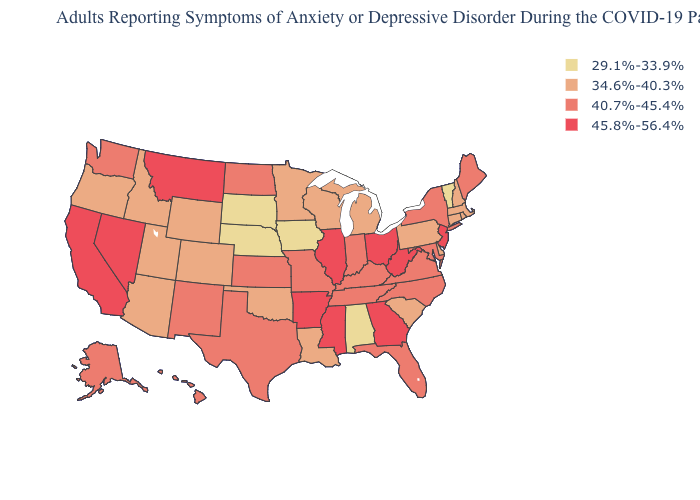Among the states that border South Dakota , does Nebraska have the lowest value?
Answer briefly. Yes. Is the legend a continuous bar?
Keep it brief. No. Name the states that have a value in the range 34.6%-40.3%?
Answer briefly. Arizona, Colorado, Connecticut, Delaware, Idaho, Louisiana, Massachusetts, Michigan, Minnesota, New Hampshire, Oklahoma, Oregon, Pennsylvania, Rhode Island, South Carolina, Utah, Wisconsin, Wyoming. How many symbols are there in the legend?
Give a very brief answer. 4. What is the lowest value in the USA?
Short answer required. 29.1%-33.9%. What is the highest value in states that border Delaware?
Quick response, please. 45.8%-56.4%. Among the states that border New Mexico , which have the lowest value?
Give a very brief answer. Arizona, Colorado, Oklahoma, Utah. Does Missouri have the lowest value in the MidWest?
Short answer required. No. Which states hav the highest value in the South?
Write a very short answer. Arkansas, Georgia, Mississippi, West Virginia. What is the highest value in states that border Washington?
Concise answer only. 34.6%-40.3%. Does Arizona have the highest value in the USA?
Be succinct. No. Is the legend a continuous bar?
Short answer required. No. Among the states that border Washington , which have the lowest value?
Keep it brief. Idaho, Oregon. What is the value of Michigan?
Give a very brief answer. 34.6%-40.3%. Name the states that have a value in the range 45.8%-56.4%?
Concise answer only. Arkansas, California, Georgia, Illinois, Mississippi, Montana, Nevada, New Jersey, Ohio, West Virginia. 